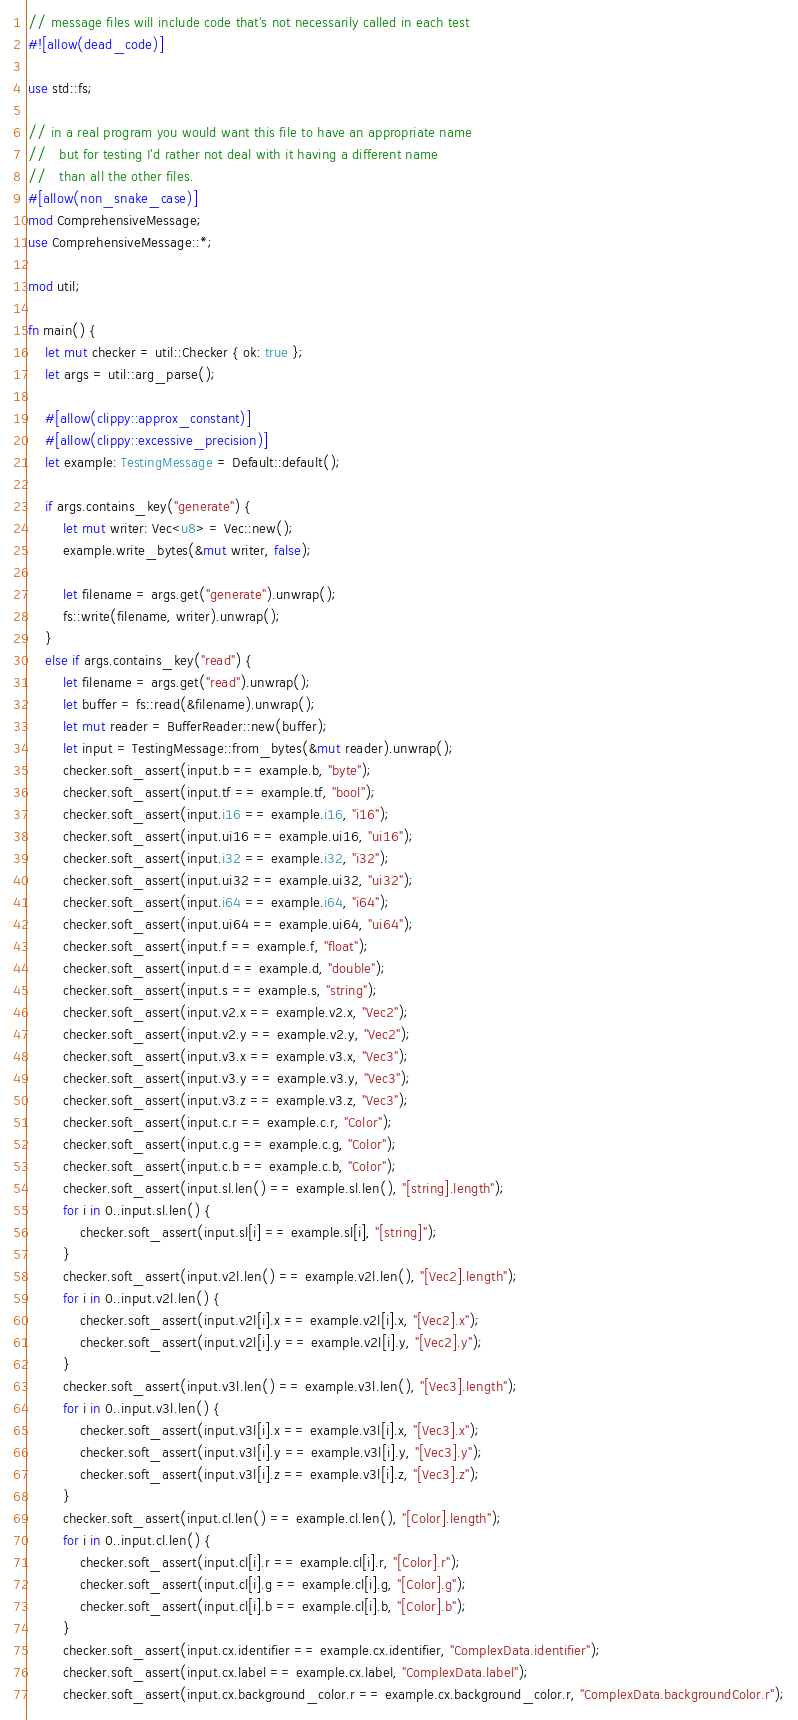<code> <loc_0><loc_0><loc_500><loc_500><_Rust_>// message files will include code that's not necessarily called in each test
#![allow(dead_code)]

use std::fs;

// in a real program you would want this file to have an appropriate name
//   but for testing I'd rather not deal with it having a different name
//   than all the other files.
#[allow(non_snake_case)]
mod ComprehensiveMessage;
use ComprehensiveMessage::*;

mod util;

fn main() {
    let mut checker = util::Checker { ok: true };
    let args = util::arg_parse();

    #[allow(clippy::approx_constant)]
    #[allow(clippy::excessive_precision)]
    let example: TestingMessage = Default::default();

    if args.contains_key("generate") {
        let mut writer: Vec<u8> = Vec::new();
        example.write_bytes(&mut writer, false);

        let filename = args.get("generate").unwrap();
        fs::write(filename, writer).unwrap();
    }
    else if args.contains_key("read") {
        let filename = args.get("read").unwrap();
        let buffer = fs::read(&filename).unwrap();
        let mut reader = BufferReader::new(buffer);
        let input = TestingMessage::from_bytes(&mut reader).unwrap();
        checker.soft_assert(input.b == example.b, "byte");
        checker.soft_assert(input.tf == example.tf, "bool");
        checker.soft_assert(input.i16 == example.i16, "i16");
        checker.soft_assert(input.ui16 == example.ui16, "ui16");
        checker.soft_assert(input.i32 == example.i32, "i32");
        checker.soft_assert(input.ui32 == example.ui32, "ui32");
        checker.soft_assert(input.i64 == example.i64, "i64");
        checker.soft_assert(input.ui64 == example.ui64, "ui64");
        checker.soft_assert(input.f == example.f, "float");
        checker.soft_assert(input.d == example.d, "double");
        checker.soft_assert(input.s == example.s, "string");
        checker.soft_assert(input.v2.x == example.v2.x, "Vec2");
        checker.soft_assert(input.v2.y == example.v2.y, "Vec2");
        checker.soft_assert(input.v3.x == example.v3.x, "Vec3");
        checker.soft_assert(input.v3.y == example.v3.y, "Vec3");
        checker.soft_assert(input.v3.z == example.v3.z, "Vec3");
        checker.soft_assert(input.c.r == example.c.r, "Color");
        checker.soft_assert(input.c.g == example.c.g, "Color");
        checker.soft_assert(input.c.b == example.c.b, "Color");
        checker.soft_assert(input.sl.len() == example.sl.len(), "[string].length");
        for i in 0..input.sl.len() {
            checker.soft_assert(input.sl[i] == example.sl[i], "[string]");
        }
        checker.soft_assert(input.v2l.len() == example.v2l.len(), "[Vec2].length");
        for i in 0..input.v2l.len() {
            checker.soft_assert(input.v2l[i].x == example.v2l[i].x, "[Vec2].x");
            checker.soft_assert(input.v2l[i].y == example.v2l[i].y, "[Vec2].y");
        }
        checker.soft_assert(input.v3l.len() == example.v3l.len(), "[Vec3].length");
        for i in 0..input.v3l.len() {
            checker.soft_assert(input.v3l[i].x == example.v3l[i].x, "[Vec3].x");
            checker.soft_assert(input.v3l[i].y == example.v3l[i].y, "[Vec3].y");
            checker.soft_assert(input.v3l[i].z == example.v3l[i].z, "[Vec3].z");
        }
        checker.soft_assert(input.cl.len() == example.cl.len(), "[Color].length");
        for i in 0..input.cl.len() {
            checker.soft_assert(input.cl[i].r == example.cl[i].r, "[Color].r");
            checker.soft_assert(input.cl[i].g == example.cl[i].g, "[Color].g");
            checker.soft_assert(input.cl[i].b == example.cl[i].b, "[Color].b");
        }
        checker.soft_assert(input.cx.identifier == example.cx.identifier, "ComplexData.identifier");
        checker.soft_assert(input.cx.label == example.cx.label, "ComplexData.label");
        checker.soft_assert(input.cx.background_color.r == example.cx.background_color.r, "ComplexData.backgroundColor.r");</code> 